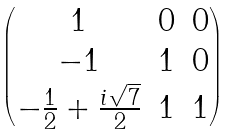<formula> <loc_0><loc_0><loc_500><loc_500>\begin{pmatrix} 1 & 0 & 0 \\ - 1 & 1 & 0 \\ - \frac { 1 } { 2 } + \frac { i \sqrt { 7 } } { 2 } & 1 & 1 \end{pmatrix}</formula> 